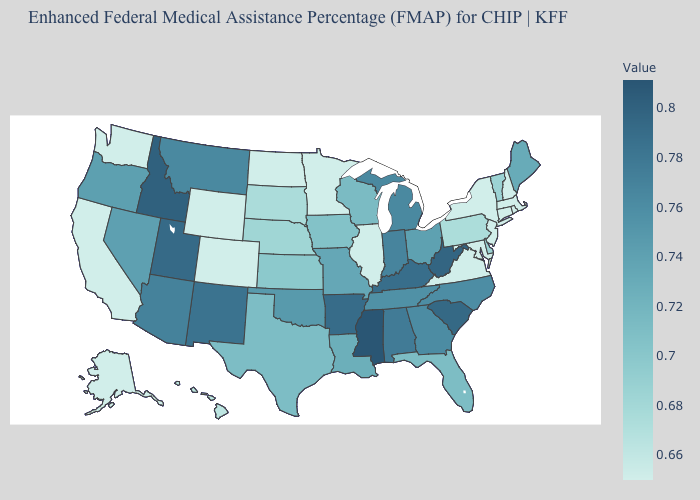Does Nevada have the highest value in the USA?
Keep it brief. No. Does Nevada have the lowest value in the West?
Keep it brief. No. Among the states that border Oklahoma , does New Mexico have the highest value?
Quick response, please. No. Which states have the lowest value in the USA?
Give a very brief answer. Alaska, California, Colorado, Connecticut, Illinois, Maryland, Massachusetts, Minnesota, New Hampshire, New Jersey, New York, North Dakota, Virginia, Washington, Wyoming. Among the states that border South Carolina , does North Carolina have the lowest value?
Concise answer only. Yes. 